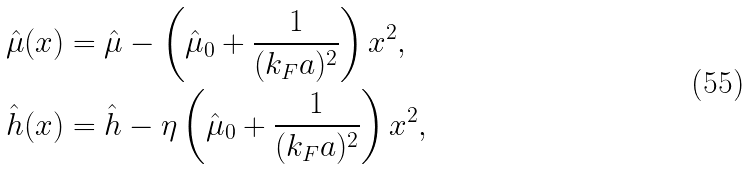Convert formula to latex. <formula><loc_0><loc_0><loc_500><loc_500>\hat { \mu } ( x ) & = \hat { \mu } - \left ( \hat { \mu } _ { 0 } + \frac { 1 } { ( k _ { F } a ) ^ { 2 } } \right ) x ^ { 2 } , \\ \hat { h } ( x ) & = \hat { h } - \eta \left ( \hat { \mu } _ { 0 } + \frac { 1 } { ( k _ { F } a ) ^ { 2 } } \right ) x ^ { 2 } ,</formula> 